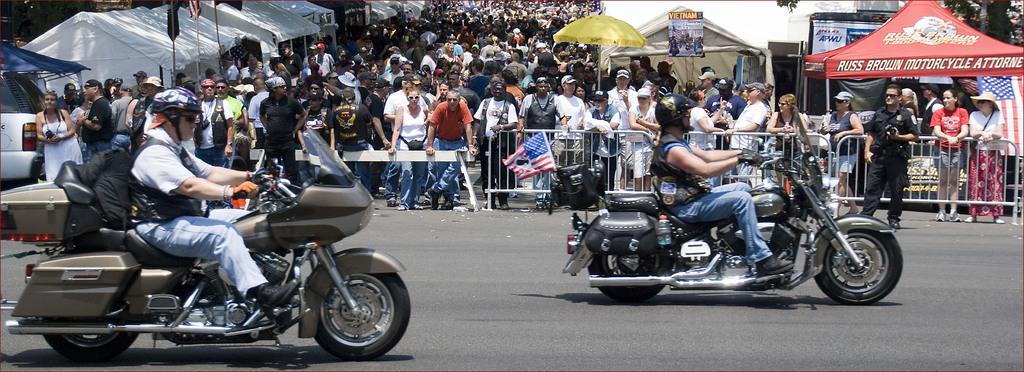How would you summarize this image in a sentence or two? In this image people are riding the bike on the road. At the back side people are standing by holding the metal grill. On both left and center of the image there are tents, flags. 